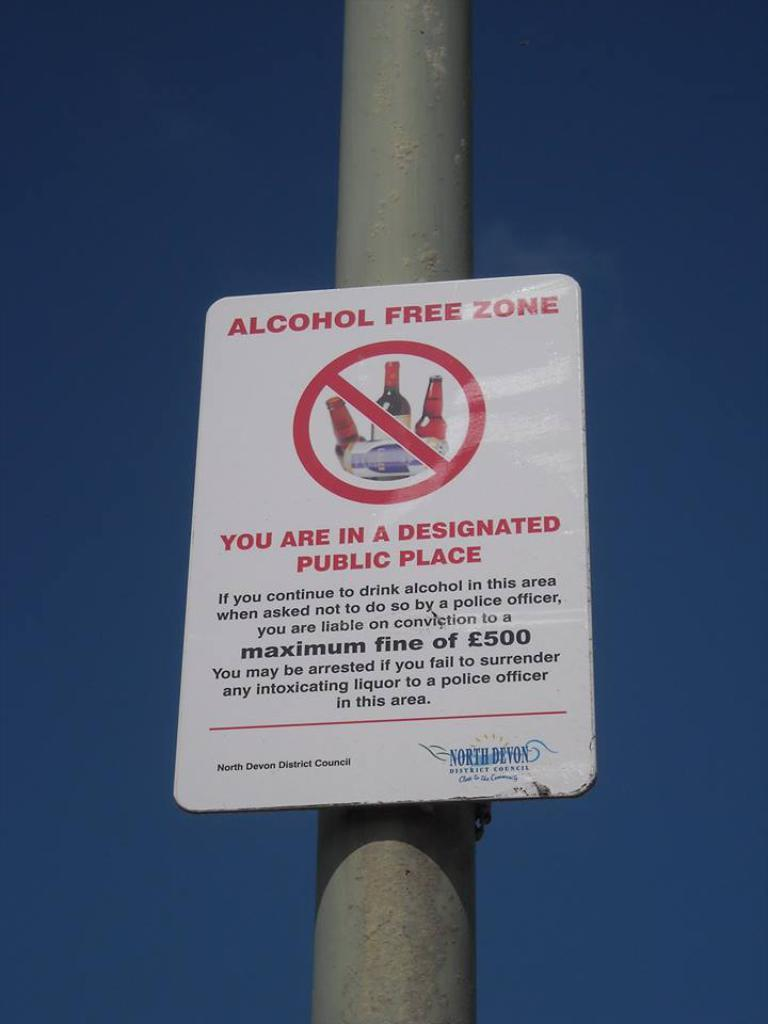<image>
Relay a brief, clear account of the picture shown. the word alcohol that is on a sign 